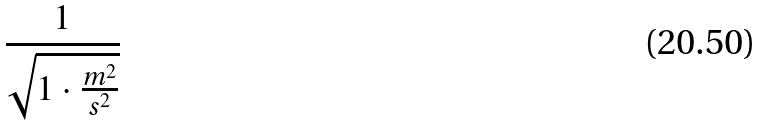<formula> <loc_0><loc_0><loc_500><loc_500>\frac { 1 } { \sqrt { 1 \cdot \frac { m ^ { 2 } } { s ^ { 2 } } } }</formula> 